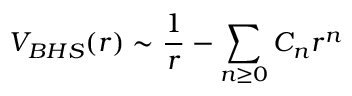Convert formula to latex. <formula><loc_0><loc_0><loc_500><loc_500>V _ { B H S } ( r ) \sim { \frac { 1 } { r } } - { \sum _ { n \geq 0 } C _ { n } r ^ { n } }</formula> 